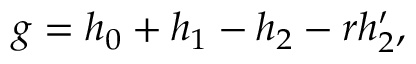<formula> <loc_0><loc_0><loc_500><loc_500>\begin{array} { r } { g = h _ { 0 } + h _ { 1 } - h _ { 2 } - r h _ { 2 } ^ { \prime } , } \end{array}</formula> 